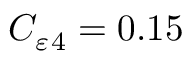Convert formula to latex. <formula><loc_0><loc_0><loc_500><loc_500>C _ { \varepsilon _ { 4 } = 0 . 1 5</formula> 